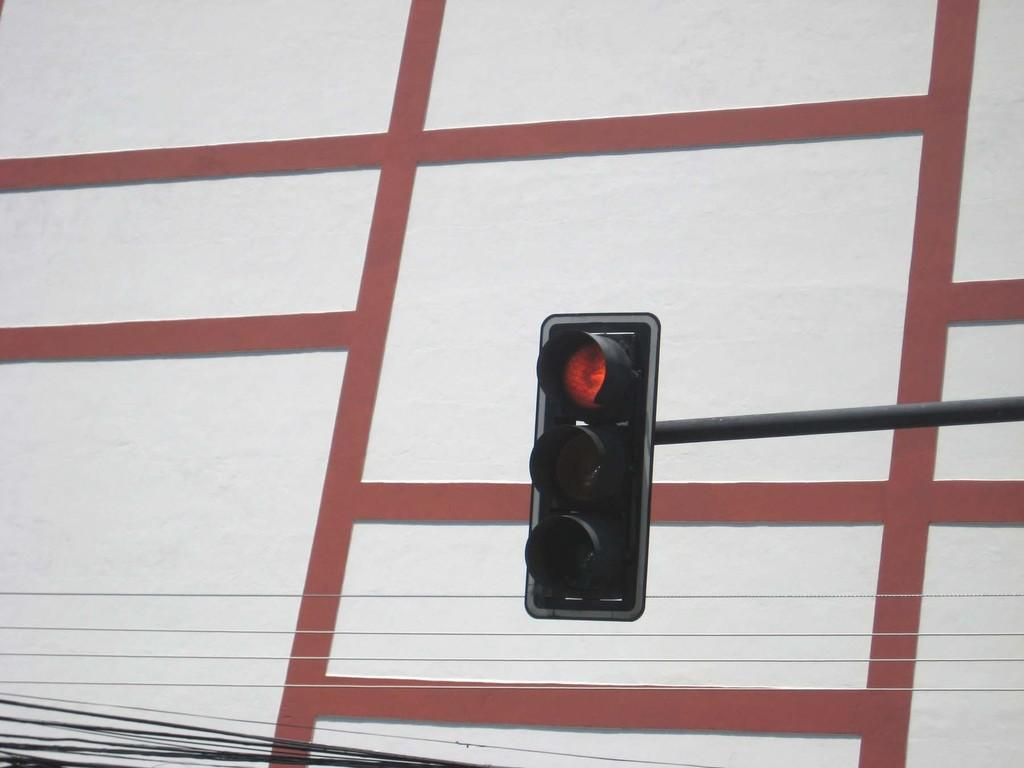What type of signaling device is present in the image? There are traffic lights in the image. What is located in the middle of the image? There is a metal rod in the middle of the image. What can be seen at the bottom of the image? There are wires at the bottom of the image. What is visible in the background of the image? There appears to be a wall in the background of the image. What direction is the traffic light facing in the image? The direction the traffic light is facing cannot be determined from the image alone. --- Facts: 1. There is a person holding a book in the image. 2. The person is sitting on a chair. 3. There is a table in front of the person. 4. The book has a blue cover. 5. The chair has a wooden frame. Absurd Topics: dance, ocean, bird Conversation: What is the person in the image holding? The person is holding a book in the image. What is the person's position in the image? The person is sitting on a chair. What is in front of the person? There is a table in front of the person. What color is the book's cover? The book has a blue cover. What is the chair made of? The chair has a wooden frame. Reasoning: Let's think step by step in order to produce the conversation. We start by identifying the main subject in the image, which is the person holding a book. Then, we expand the conversation to include other items that are also visible, such as the chair, table, and the book's cover color. Each question is designed to elicit a specific detail about the image that is known from the provided facts. Absurd Question/Answer: Can you see any ocean waves in the image? There is no ocean or waves present in the image. 